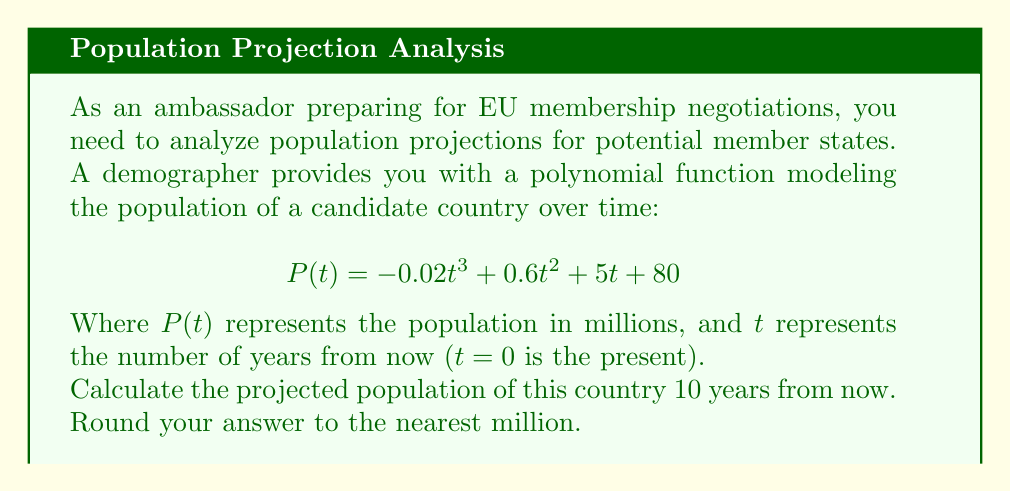Help me with this question. To solve this problem, we need to evaluate the given polynomial function at $t = 10$. Let's break it down step-by-step:

1) The given function is:
   $$P(t) = -0.02t^3 + 0.6t^2 + 5t + 80$$

2) We need to calculate $P(10)$. Let's substitute $t = 10$ into the equation:
   $$P(10) = -0.02(10)^3 + 0.6(10)^2 + 5(10) + 80$$

3) Now, let's evaluate each term:
   - $-0.02(10)^3 = -0.02 * 1000 = -20$
   - $0.6(10)^2 = 0.6 * 100 = 60$
   - $5(10) = 50$
   - The constant term is already 80

4) Sum up all the terms:
   $$P(10) = -20 + 60 + 50 + 80 = 170$$

5) The result is 170 million. As per the question, we need to round to the nearest million, but 170 is already a whole number of millions, so no further rounding is necessary.
Answer: 170 million 